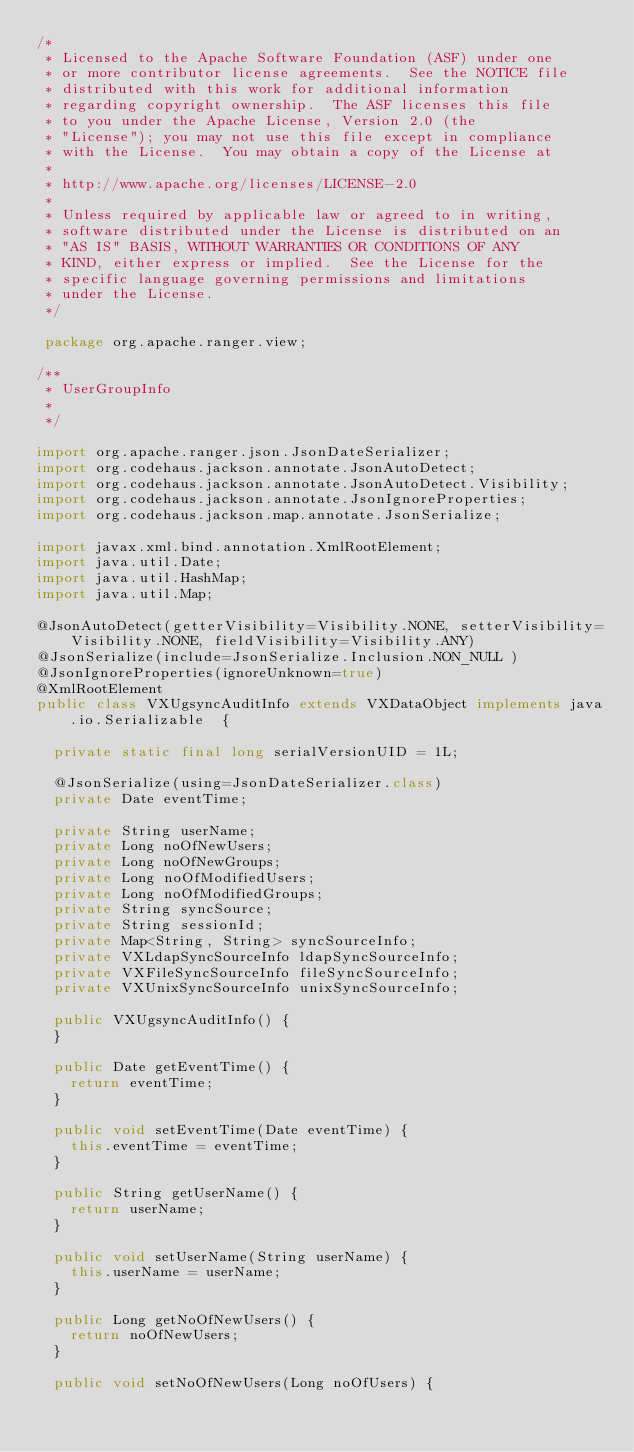Convert code to text. <code><loc_0><loc_0><loc_500><loc_500><_Java_>/*
 * Licensed to the Apache Software Foundation (ASF) under one
 * or more contributor license agreements.  See the NOTICE file
 * distributed with this work for additional information
 * regarding copyright ownership.  The ASF licenses this file
 * to you under the Apache License, Version 2.0 (the
 * "License"); you may not use this file except in compliance
 * with the License.  You may obtain a copy of the License at
 *
 * http://www.apache.org/licenses/LICENSE-2.0
 *
 * Unless required by applicable law or agreed to in writing,
 * software distributed under the License is distributed on an
 * "AS IS" BASIS, WITHOUT WARRANTIES OR CONDITIONS OF ANY
 * KIND, either express or implied.  See the License for the
 * specific language governing permissions and limitations
 * under the License.
 */

 package org.apache.ranger.view;

/**
 * UserGroupInfo
 *
 */

import org.apache.ranger.json.JsonDateSerializer;
import org.codehaus.jackson.annotate.JsonAutoDetect;
import org.codehaus.jackson.annotate.JsonAutoDetect.Visibility;
import org.codehaus.jackson.annotate.JsonIgnoreProperties;
import org.codehaus.jackson.map.annotate.JsonSerialize;

import javax.xml.bind.annotation.XmlRootElement;
import java.util.Date;
import java.util.HashMap;
import java.util.Map;

@JsonAutoDetect(getterVisibility=Visibility.NONE, setterVisibility=Visibility.NONE, fieldVisibility=Visibility.ANY)
@JsonSerialize(include=JsonSerialize.Inclusion.NON_NULL )
@JsonIgnoreProperties(ignoreUnknown=true)
@XmlRootElement
public class VXUgsyncAuditInfo extends VXDataObject implements java.io.Serializable  {

	private static final long serialVersionUID = 1L;

	@JsonSerialize(using=JsonDateSerializer.class)
	private Date eventTime;

	private String userName;
	private Long noOfNewUsers;
	private Long noOfNewGroups;
	private Long noOfModifiedUsers;
	private Long noOfModifiedGroups;
	private String syncSource;
	private String sessionId;
	private Map<String, String> syncSourceInfo;
	private VXLdapSyncSourceInfo ldapSyncSourceInfo;
	private VXFileSyncSourceInfo fileSyncSourceInfo;
	private VXUnixSyncSourceInfo unixSyncSourceInfo;

	public VXUgsyncAuditInfo() {
	}

	public Date getEventTime() {
		return eventTime;
	}

	public void setEventTime(Date eventTime) {
		this.eventTime = eventTime;
	}

	public String getUserName() {
		return userName;
	}

	public void setUserName(String userName) {
		this.userName = userName;
	}

	public Long getNoOfNewUsers() {
		return noOfNewUsers;
	}

	public void setNoOfNewUsers(Long noOfUsers) {</code> 